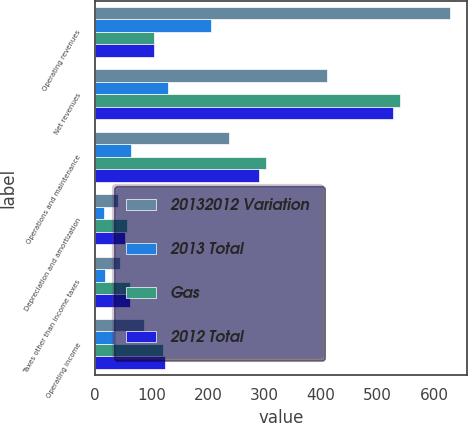<chart> <loc_0><loc_0><loc_500><loc_500><stacked_bar_chart><ecel><fcel>Operating revenues<fcel>Net revenues<fcel>Operations and maintenance<fcel>Depreciation and amortization<fcel>Taxes other than income taxes<fcel>Operating income<nl><fcel>20132012 Variation<fcel>628<fcel>411<fcel>238<fcel>41<fcel>45<fcel>87<nl><fcel>2013 Total<fcel>205<fcel>129<fcel>64<fcel>15<fcel>17<fcel>33<nl><fcel>Gas<fcel>103.5<fcel>540<fcel>302<fcel>56<fcel>62<fcel>120<nl><fcel>2012 Total<fcel>103.5<fcel>528<fcel>291<fcel>53<fcel>61<fcel>123<nl></chart> 